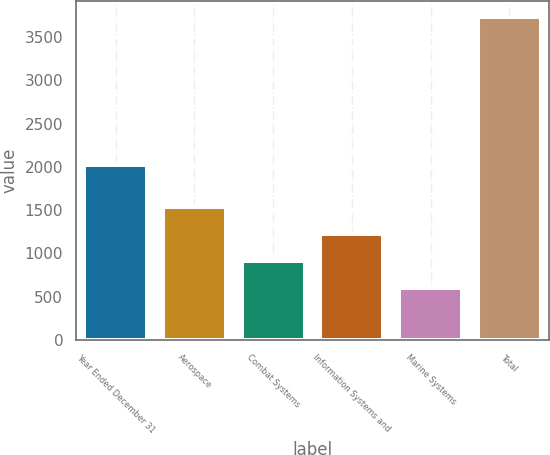Convert chart. <chart><loc_0><loc_0><loc_500><loc_500><bar_chart><fcel>Year Ended December 31<fcel>Aerospace<fcel>Combat Systems<fcel>Information Systems and<fcel>Marine Systems<fcel>Total<nl><fcel>2016<fcel>1536.7<fcel>908.9<fcel>1222.8<fcel>595<fcel>3734<nl></chart> 